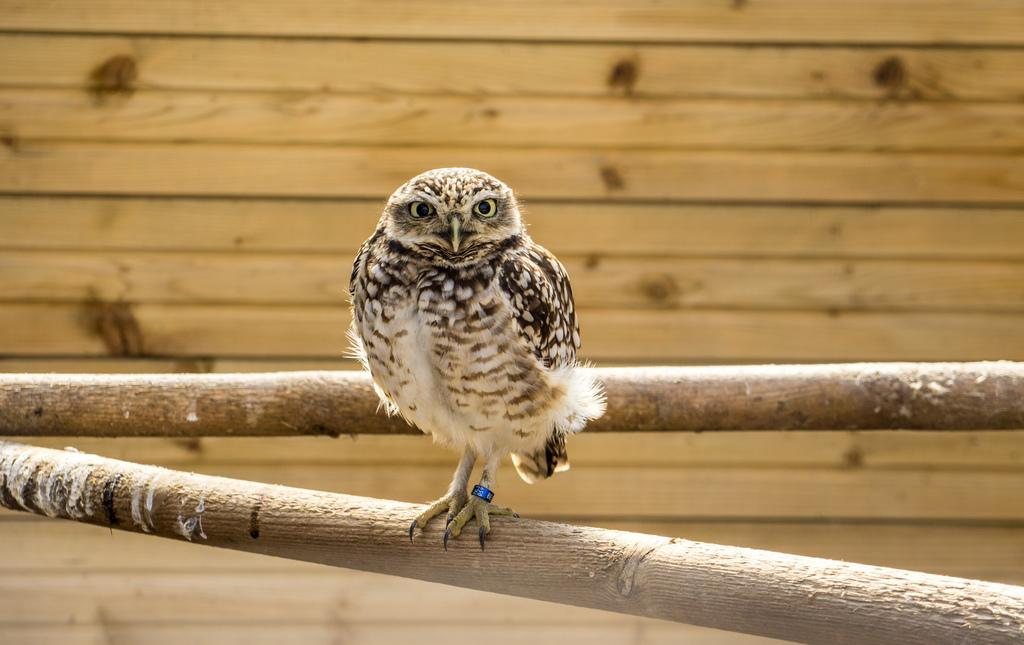What type of animal is in the image? There is an owl in the image. What is the owl sitting on? The owl is on wooden sticks. What can be seen in the background of the image? There is a wooden wall in the background of the image. What type of banana is hanging from the wooden wall in the image? There is no banana present in the image; it features an owl on wooden sticks and a wooden wall in the background. How does the wooden wall affect the acoustics in the room? The provided facts do not give enough information to determine how the wooden wall affects the acoustics in the room. 